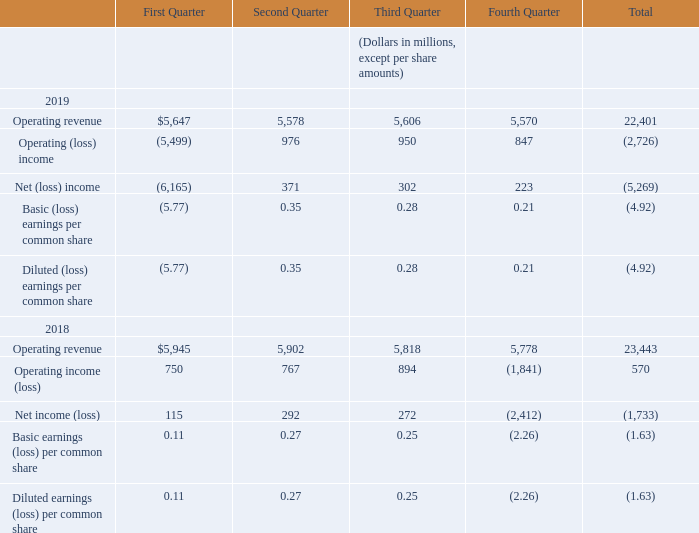(18) Quarterly Financial Data (Unaudited)
During the first quarter of 2019, we recorded a non-cash, non-tax-deductible goodwill impairment charge of $6.5 billion for goodwill, see Note 4—Goodwill, Customer Relationships and Other Intangible Assets for further details.
During the fourth quarter of 2018, we recorded a non-cash, non-tax-deductible goodwill impairment charge of $2.7 billion for goodwill see Note 4—Goodwill, Customer Relationships and Other Intangible Assets for further details.
During the first quarter of 2018, we recognized $71 million of expenses related to our acquisition of Level 3 followed by acquisition-related expenses of $162 million, $43 million and $117 million in the second, third and fourth quarters of 2018, respectively. During 2019, we recognized expenses related to our acquisition of Level 3 of $34 million, $39 million, $38 million and $123 million in the first, second, third and fourth quarters of 2019, respectively.
What is the total operating revenue recorded in 2019?
Answer scale should be: million. 22,401. What is the total Operating (loss) income recorded in 2018?
Answer scale should be: million. 570. In which periods was a non-cash, non-tax-deductible goodwill impairment charge recorded? First quarter of 2019, fourth quarter of 2018. Which quarter in 2019 has the largest operating revenue? 5,647>5,606>5,578>5,570
Answer: first quarter. What is the total amount of expenses related to the acquisition of Level 3 recorded in 2019?
Answer scale should be: million. 34+39+38+123
Answer: 234. What is the average quarterly amount of expenses related to the acquisition of Level 3 recorded in 2019?
Answer scale should be: million. (34+39+38+123)/4
Answer: 58.5. 